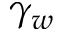<formula> <loc_0><loc_0><loc_500><loc_500>\gamma _ { w }</formula> 